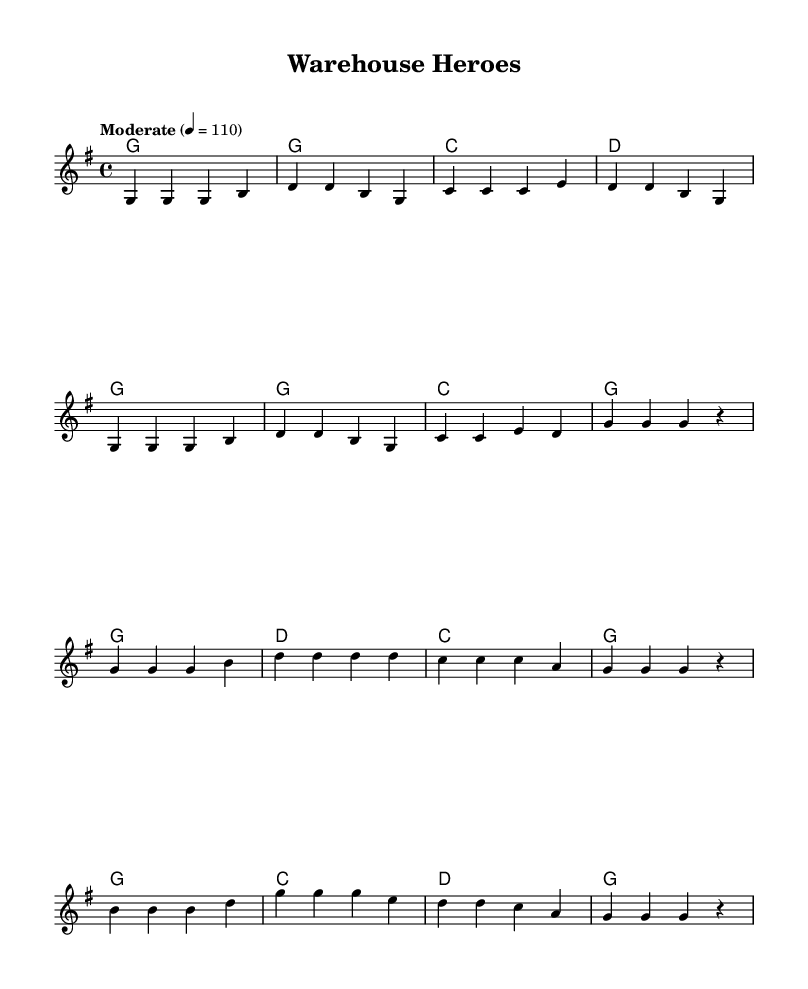What is the key signature of this music? The key signature is G major, which has one sharp (F#). It is indicated at the beginning of the sheet music.
Answer: G major What is the time signature of this music? The time signature is found at the beginning of the sheet music, showing that there are 4 beats in a measure and the quarter note gets one beat.
Answer: 4/4 What is the tempo marking of this music? The tempo marking indicates the speed at which the piece should be played, and it is stated as 'Moderate' with a metronome marking of 110 beats per minute.
Answer: Moderate How many lines are in the chorus section of the song? To determine this, I count the lines of lyrics specifically designated for the chorus in the sheet music. The chorus lyrics are grouped in four lines.
Answer: Four What type of lyrics are used in this song? The lyrics tell a story of dedication and hard work related to warehouse employees, common in Country music themes that celebrate everyday life and labor.
Answer: Narrative Which chord appears most frequently in the verse? By examining the harmonies listed for the verse, the chord 'G' is repeated the most often in the chord progressions.
Answer: G What is the last note in the melody of the chorus? The last note of the melody is indicated in the final measure of the chorus section, and it is a rest, implying no note is played.
Answer: Rest 